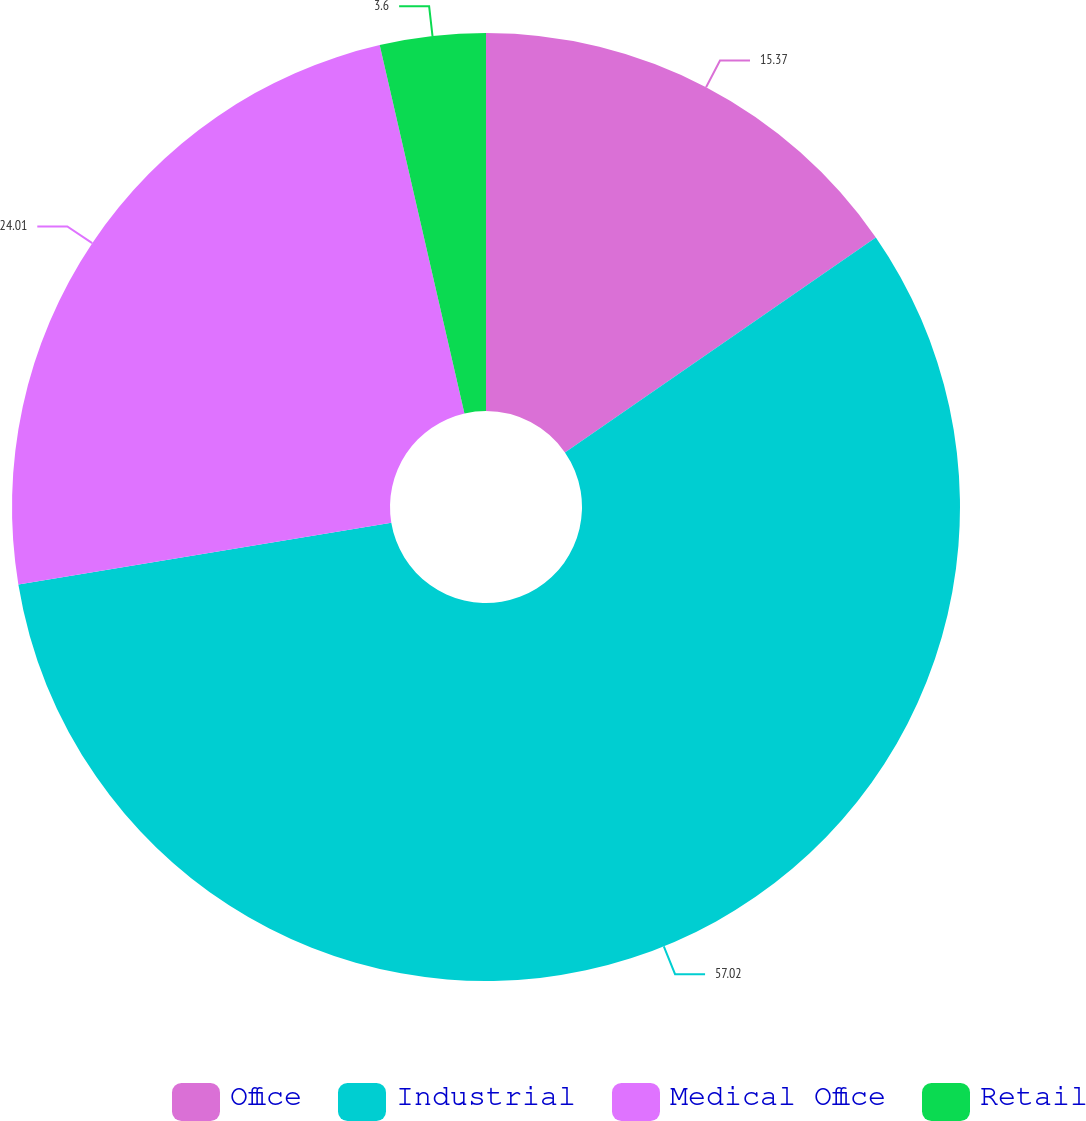Convert chart to OTSL. <chart><loc_0><loc_0><loc_500><loc_500><pie_chart><fcel>Office<fcel>Industrial<fcel>Medical Office<fcel>Retail<nl><fcel>15.37%<fcel>57.02%<fcel>24.01%<fcel>3.6%<nl></chart> 